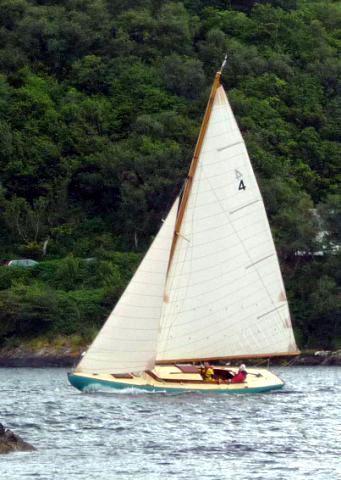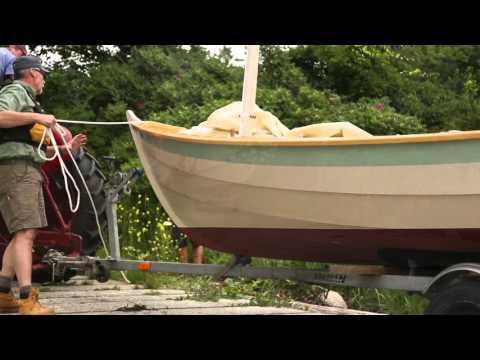The first image is the image on the left, the second image is the image on the right. Considering the images on both sides, is "Each image shows a boat on the water, and at least one of the boats looks like a wooden model instead of a full-size boat." valid? Answer yes or no. No. The first image is the image on the left, the second image is the image on the right. Assess this claim about the two images: "Both of the boats are in the water.". Correct or not? Answer yes or no. No. 